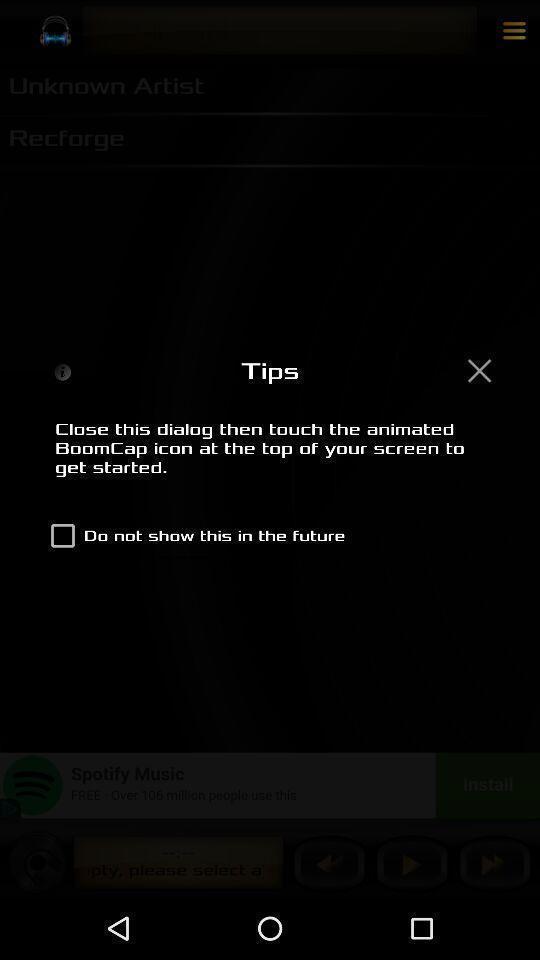Explain what's happening in this screen capture. Pop up showing about tips. 